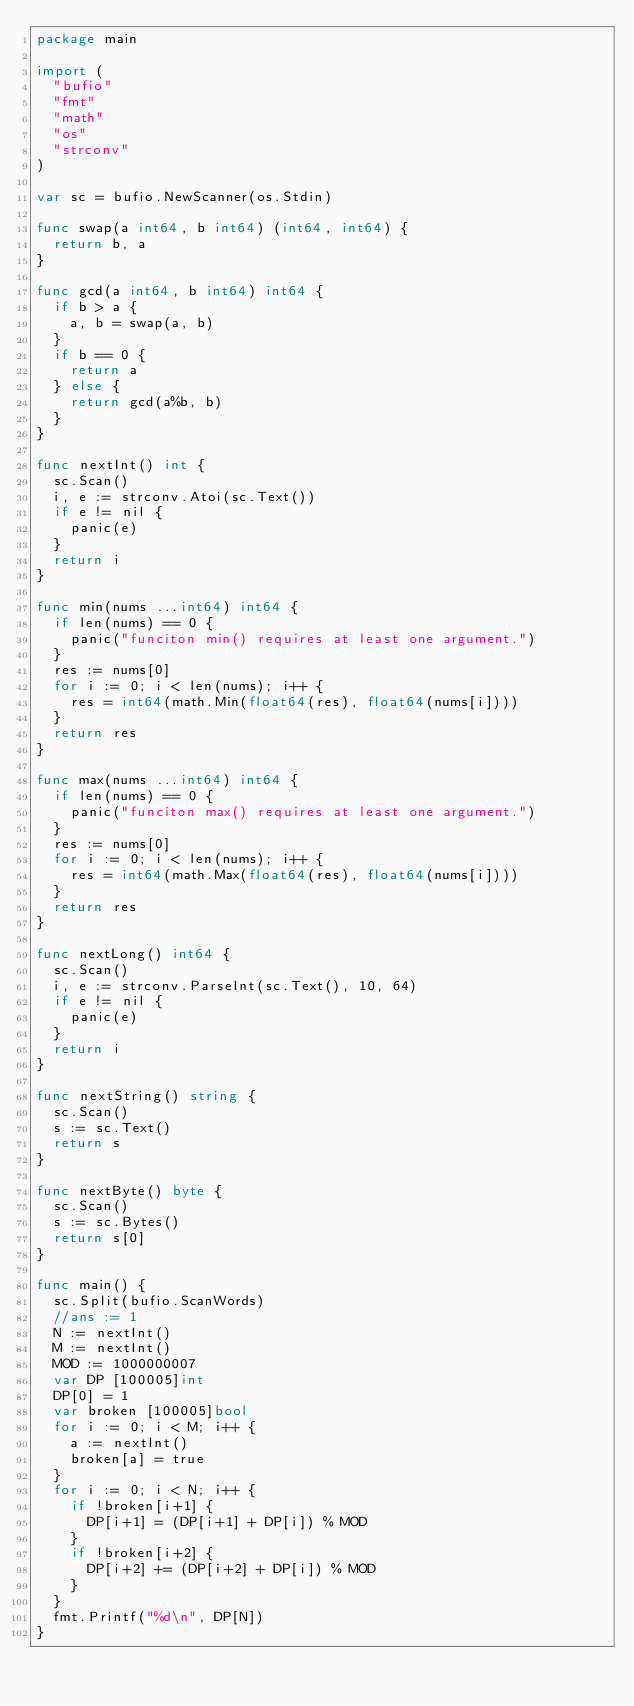<code> <loc_0><loc_0><loc_500><loc_500><_Go_>package main

import (
	"bufio"
	"fmt"
	"math"
	"os"
	"strconv"
)

var sc = bufio.NewScanner(os.Stdin)

func swap(a int64, b int64) (int64, int64) {
	return b, a
}

func gcd(a int64, b int64) int64 {
	if b > a {
		a, b = swap(a, b)
	}
	if b == 0 {
		return a
	} else {
		return gcd(a%b, b)
	}
}

func nextInt() int {
	sc.Scan()
	i, e := strconv.Atoi(sc.Text())
	if e != nil {
		panic(e)
	}
	return i
}

func min(nums ...int64) int64 {
	if len(nums) == 0 {
		panic("funciton min() requires at least one argument.")
	}
	res := nums[0]
	for i := 0; i < len(nums); i++ {
		res = int64(math.Min(float64(res), float64(nums[i])))
	}
	return res
}

func max(nums ...int64) int64 {
	if len(nums) == 0 {
		panic("funciton max() requires at least one argument.")
	}
	res := nums[0]
	for i := 0; i < len(nums); i++ {
		res = int64(math.Max(float64(res), float64(nums[i])))
	}
	return res
}

func nextLong() int64 {
	sc.Scan()
	i, e := strconv.ParseInt(sc.Text(), 10, 64)
	if e != nil {
		panic(e)
	}
	return i
}

func nextString() string {
	sc.Scan()
	s := sc.Text()
	return s
}

func nextByte() byte {
	sc.Scan()
	s := sc.Bytes()
	return s[0]
}

func main() {
	sc.Split(bufio.ScanWords)
	//ans := 1
	N := nextInt()
	M := nextInt()
	MOD := 1000000007
	var DP [100005]int
	DP[0] = 1
	var broken [100005]bool
	for i := 0; i < M; i++ {
		a := nextInt()
		broken[a] = true
	}
	for i := 0; i < N; i++ {
		if !broken[i+1] {
			DP[i+1] = (DP[i+1] + DP[i]) % MOD
		}
		if !broken[i+2] {
			DP[i+2] += (DP[i+2] + DP[i]) % MOD
		}
	}
	fmt.Printf("%d\n", DP[N])
}
</code> 